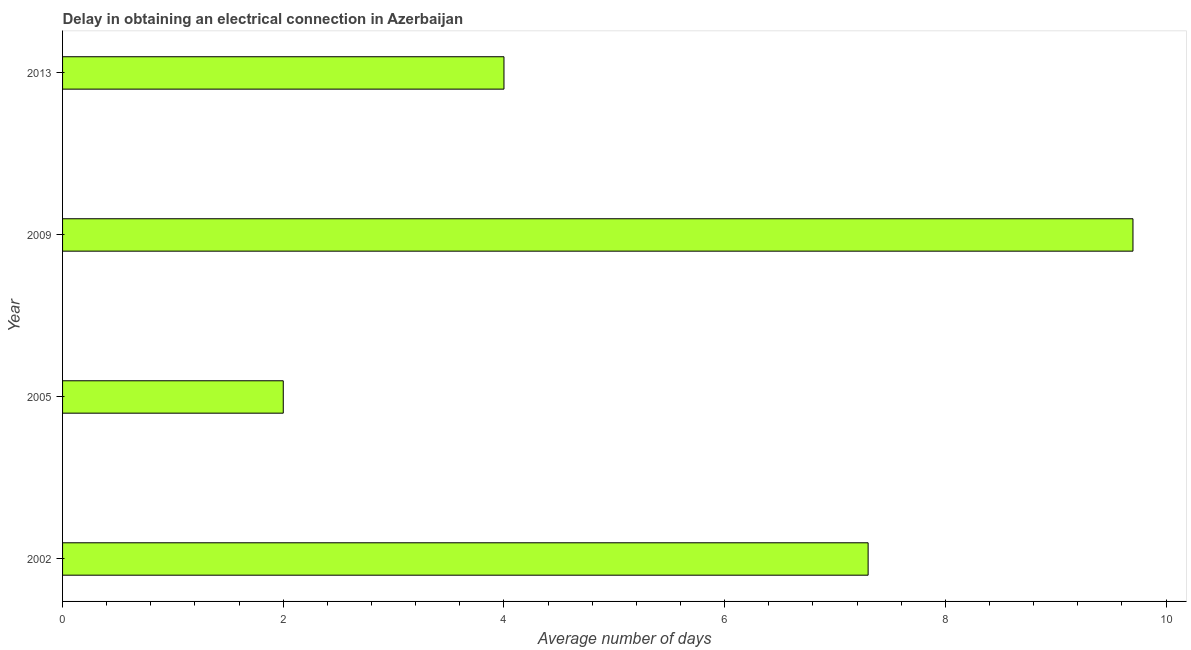Does the graph contain any zero values?
Give a very brief answer. No. What is the title of the graph?
Your response must be concise. Delay in obtaining an electrical connection in Azerbaijan. What is the label or title of the X-axis?
Ensure brevity in your answer.  Average number of days. Across all years, what is the minimum dalay in electrical connection?
Give a very brief answer. 2. What is the sum of the dalay in electrical connection?
Provide a short and direct response. 23. What is the average dalay in electrical connection per year?
Provide a short and direct response. 5.75. What is the median dalay in electrical connection?
Provide a succinct answer. 5.65. In how many years, is the dalay in electrical connection greater than 1.6 days?
Give a very brief answer. 4. What is the ratio of the dalay in electrical connection in 2009 to that in 2013?
Your response must be concise. 2.42. Is the sum of the dalay in electrical connection in 2002 and 2009 greater than the maximum dalay in electrical connection across all years?
Provide a short and direct response. Yes. In how many years, is the dalay in electrical connection greater than the average dalay in electrical connection taken over all years?
Give a very brief answer. 2. How many years are there in the graph?
Give a very brief answer. 4. What is the difference between two consecutive major ticks on the X-axis?
Provide a short and direct response. 2. What is the Average number of days in 2005?
Your response must be concise. 2. What is the Average number of days in 2009?
Your answer should be very brief. 9.7. What is the difference between the Average number of days in 2002 and 2005?
Make the answer very short. 5.3. What is the difference between the Average number of days in 2002 and 2009?
Provide a succinct answer. -2.4. What is the difference between the Average number of days in 2002 and 2013?
Provide a succinct answer. 3.3. What is the difference between the Average number of days in 2009 and 2013?
Provide a succinct answer. 5.7. What is the ratio of the Average number of days in 2002 to that in 2005?
Provide a short and direct response. 3.65. What is the ratio of the Average number of days in 2002 to that in 2009?
Provide a succinct answer. 0.75. What is the ratio of the Average number of days in 2002 to that in 2013?
Offer a very short reply. 1.82. What is the ratio of the Average number of days in 2005 to that in 2009?
Keep it short and to the point. 0.21. What is the ratio of the Average number of days in 2005 to that in 2013?
Your response must be concise. 0.5. What is the ratio of the Average number of days in 2009 to that in 2013?
Make the answer very short. 2.42. 